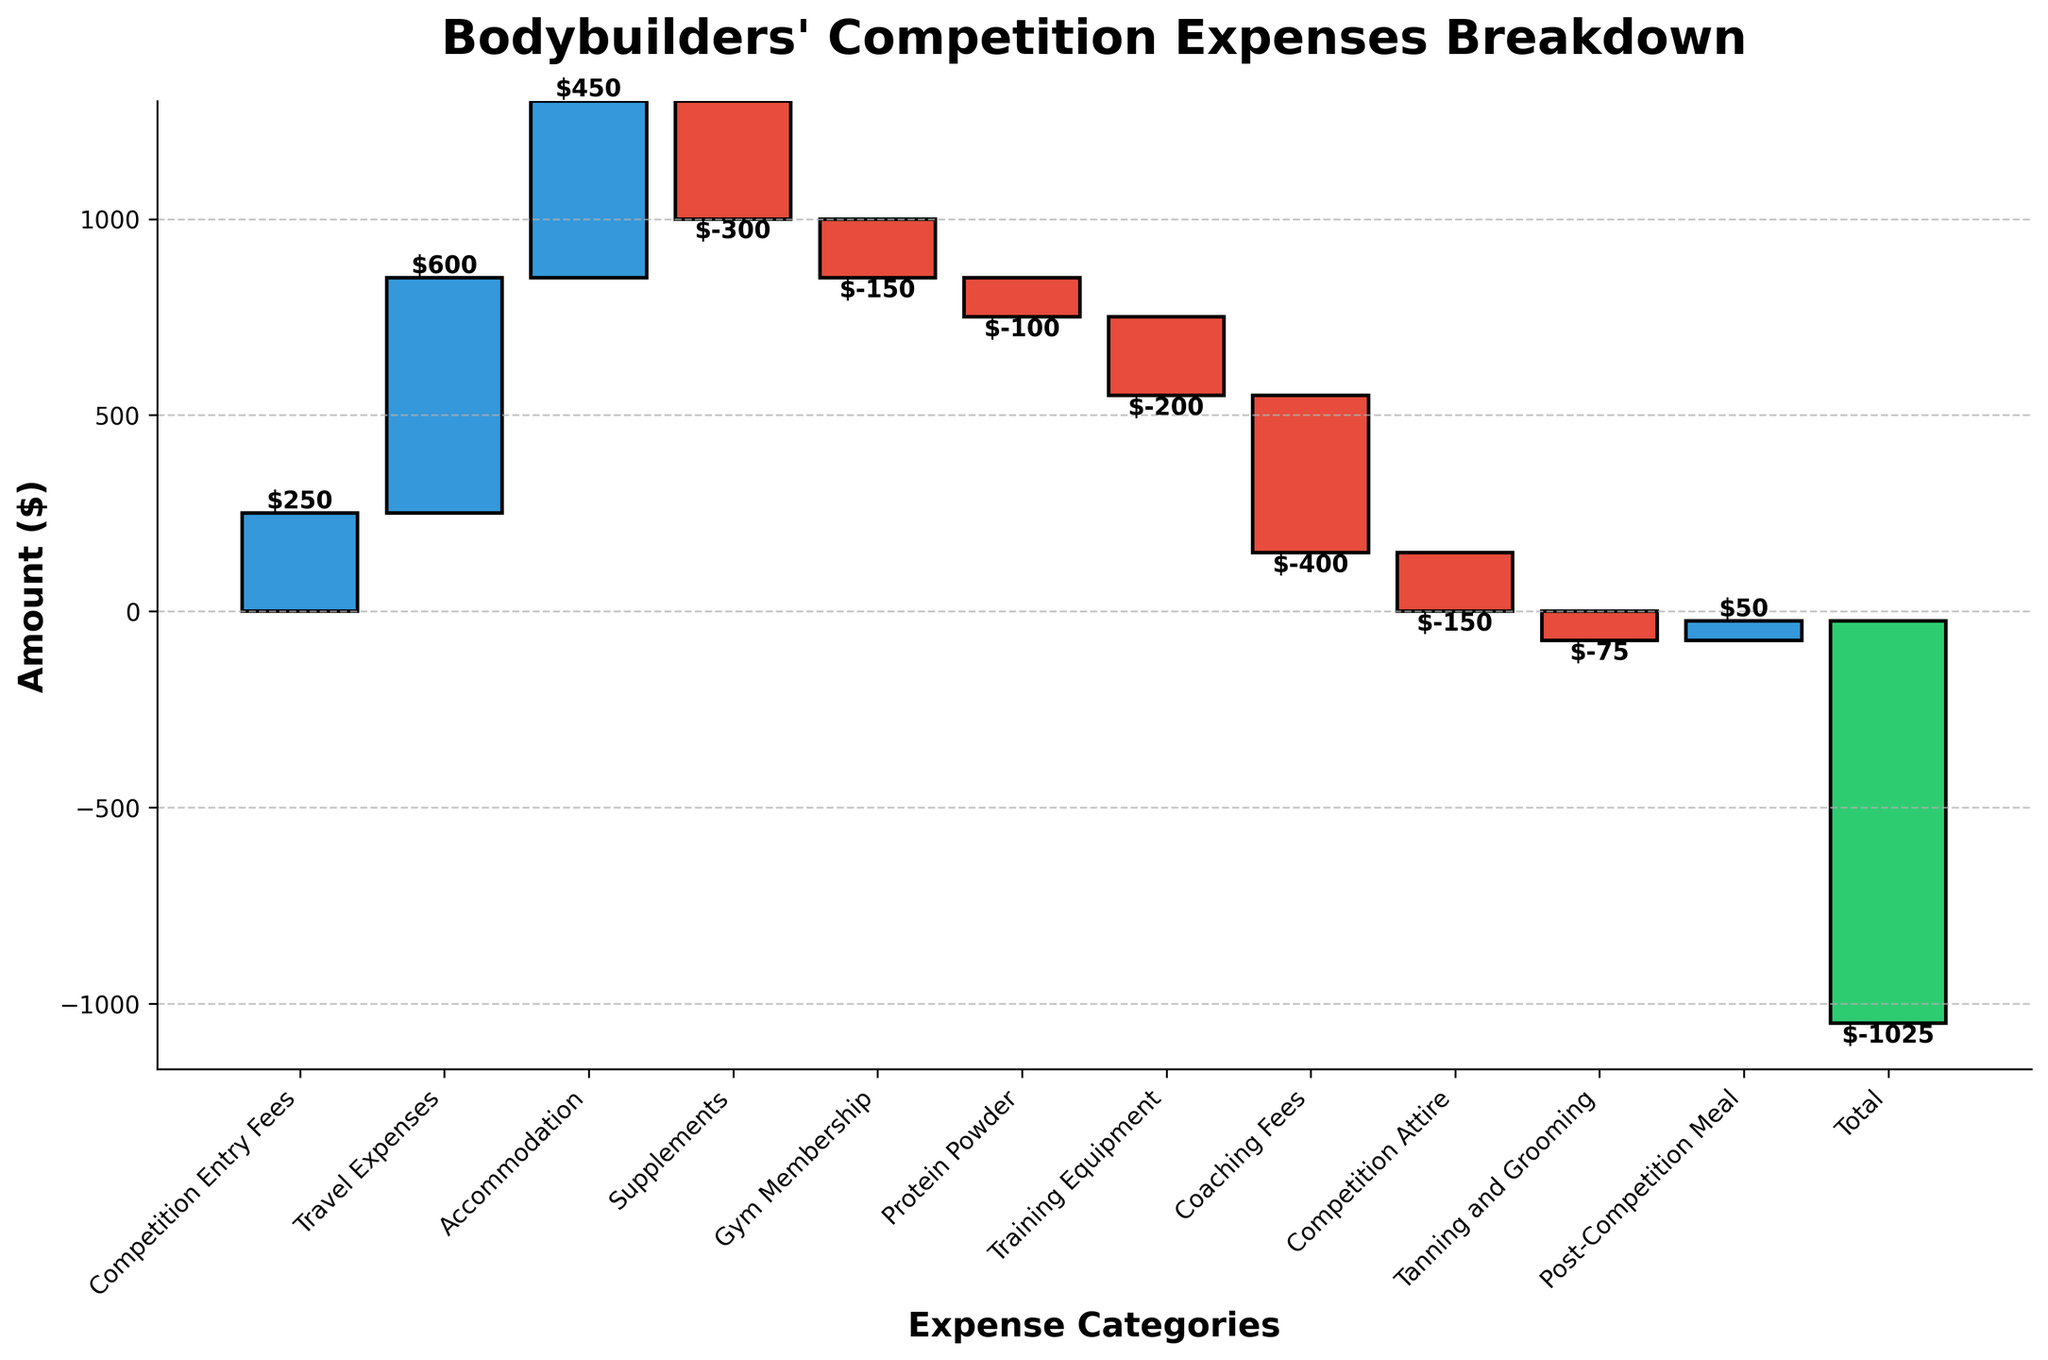How much are the total competition entry fees? Refer to the "Competition Entry Fees" bar, which shows the amount is $250
Answer: $250 Which expense category has the highest cost? Check the height of the bars and find the maximum. "Travel Expenses" bar is the tallest, indicating it has the highest cost
Answer: Travel Expenses What is the total expense for supplements, gym membership, and protein powder? Add the amounts for "Supplements" (-$300), "Gym Membership" (-$150), and "Protein Powder" (-$100): -300 + -150 + -100 = -550
Answer: -$550 Does the expense for coaching fees exceed the expense for training equipment? Compare the height of the "Coaching Fees" bar (-$400) with the "Training Equipment" bar (-$200). Coaching fees are higher in absolute value
Answer: Yes Which expense falls under grooming needs? Identify the category related to grooming in the list, "Tanning and Grooming," with an amount of -$75
Answer: Tanning and Grooming How much is the net total of all expenses combined? Check the final bar labeled "Total," which shows the sum of all expenses is -$1025
Answer: -$1025 What is the sum of travel expenses and accommodation costs? Add the amounts for "Travel Expenses" ($600) and "Accommodation" ($450): 600 + 450 = 1050
Answer: $1050 Is the amount spent on competition attire less than the amount spent on protein powder? Compare the "Competition Attire" bar (-$150) with the "Protein Powder" bar (-$100). The expense for competition attire is greater in absolute terms
Answer: No How much is spent on post-competition meal? Refer to the "Post-Competition Meal" bar, showing the amount is $50
Answer: $50 Which expense category has the smallest cost? Find the smallest bar or the one with the least negative value, which is "Tanning and Grooming" at -$75
Answer: Tanning and Grooming 